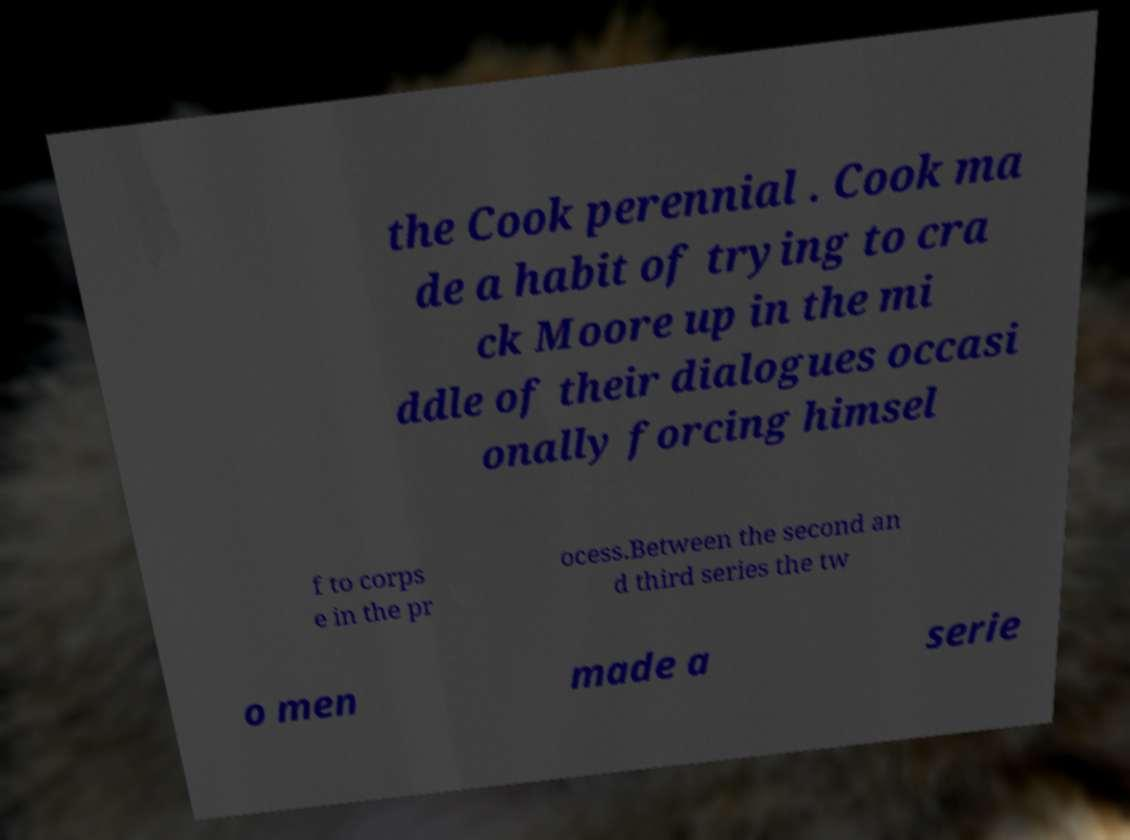Can you accurately transcribe the text from the provided image for me? the Cook perennial . Cook ma de a habit of trying to cra ck Moore up in the mi ddle of their dialogues occasi onally forcing himsel f to corps e in the pr ocess.Between the second an d third series the tw o men made a serie 